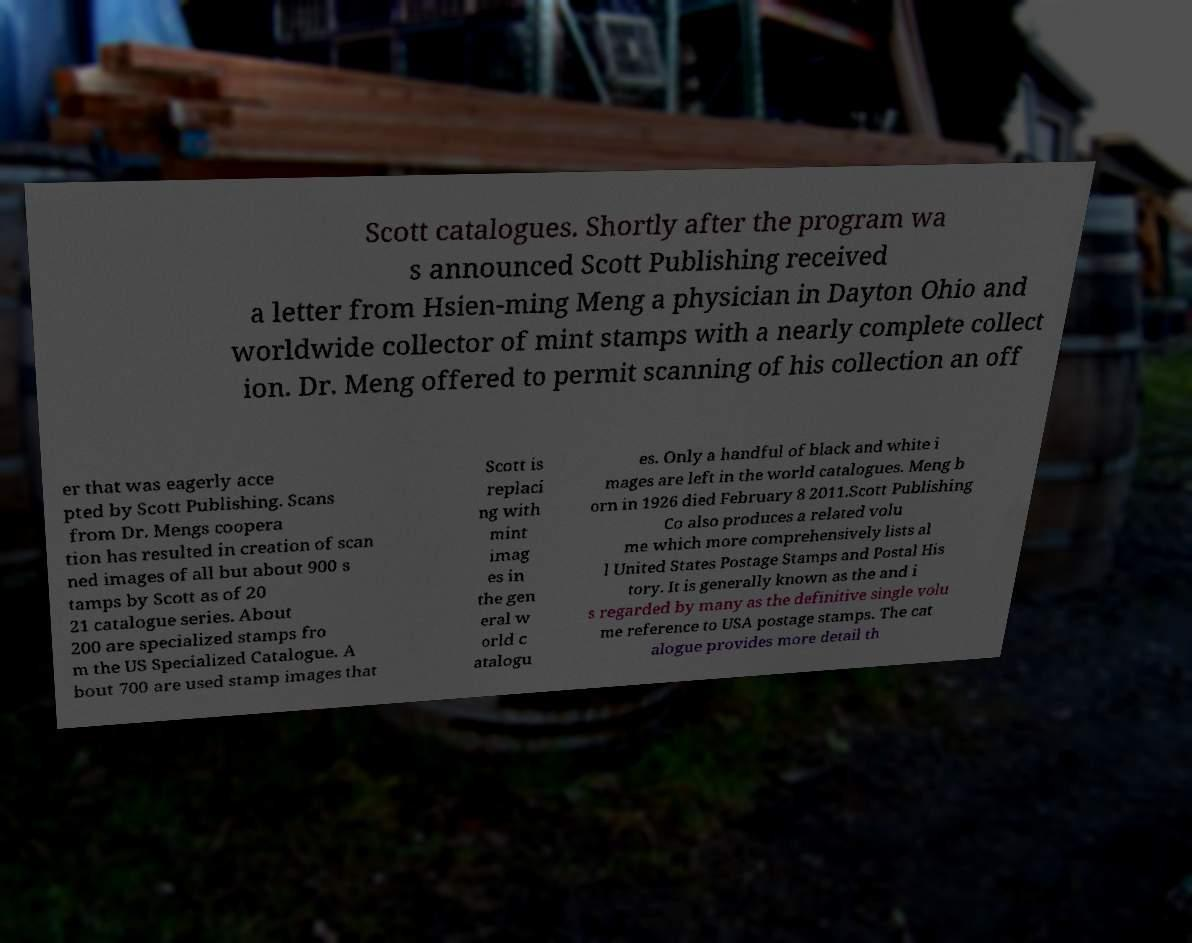Can you read and provide the text displayed in the image?This photo seems to have some interesting text. Can you extract and type it out for me? Scott catalogues. Shortly after the program wa s announced Scott Publishing received a letter from Hsien-ming Meng a physician in Dayton Ohio and worldwide collector of mint stamps with a nearly complete collect ion. Dr. Meng offered to permit scanning of his collection an off er that was eagerly acce pted by Scott Publishing. Scans from Dr. Mengs coopera tion has resulted in creation of scan ned images of all but about 900 s tamps by Scott as of 20 21 catalogue series. About 200 are specialized stamps fro m the US Specialized Catalogue. A bout 700 are used stamp images that Scott is replaci ng with mint imag es in the gen eral w orld c atalogu es. Only a handful of black and white i mages are left in the world catalogues. Meng b orn in 1926 died February 8 2011.Scott Publishing Co also produces a related volu me which more comprehensively lists al l United States Postage Stamps and Postal His tory. It is generally known as the and i s regarded by many as the definitive single volu me reference to USA postage stamps. The cat alogue provides more detail th 